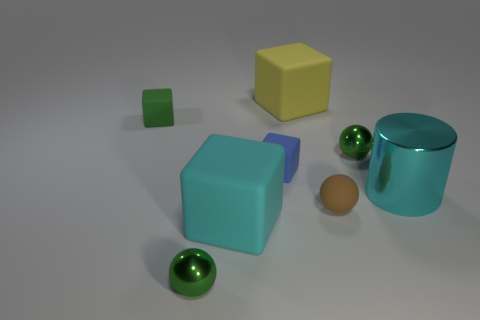How would you describe the lighting and shadows in the scene? The lighting in the scene appears to be soft and diffused, with minimal harsh shadows. It's likely the light source is positioned overhead, as evidenced by the subtle shadows cast directly beneath the objects. These shadows help to enhance the three-dimensional quality of the objects and provide a sense of the spatial relationships between them. 